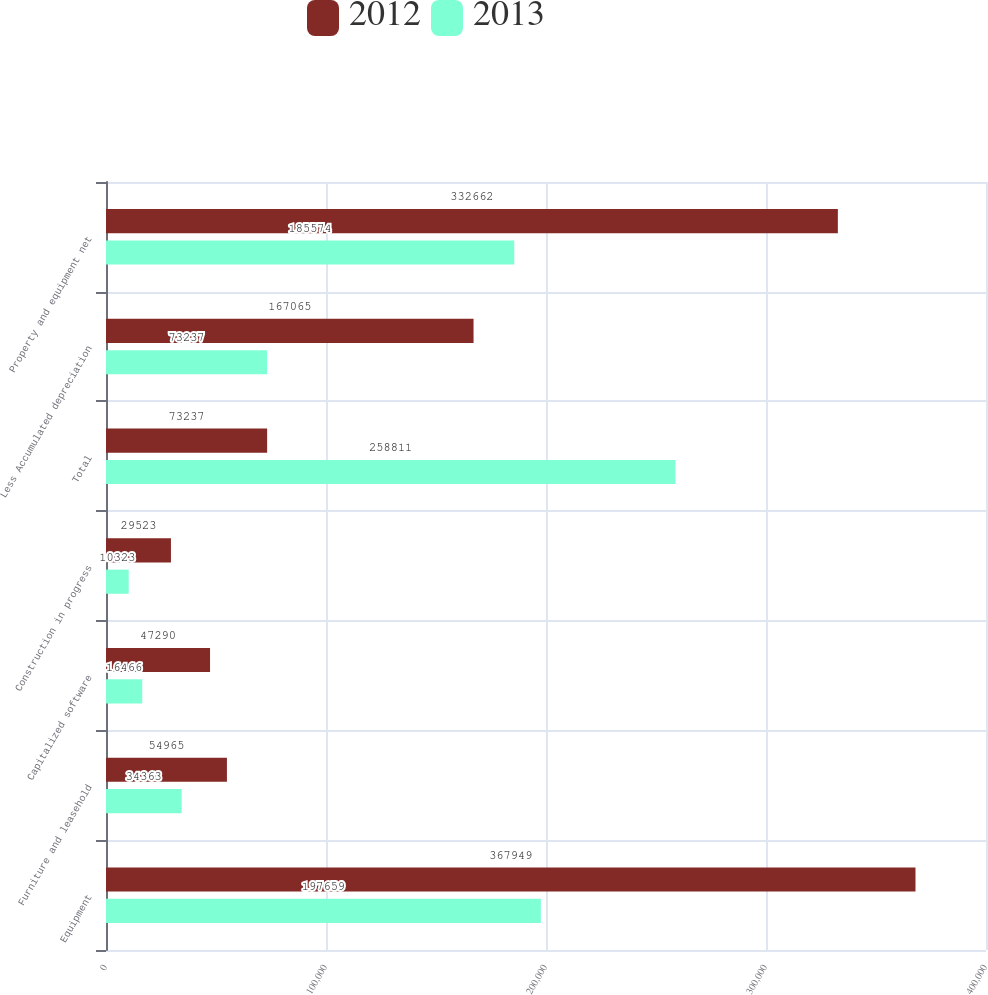Convert chart to OTSL. <chart><loc_0><loc_0><loc_500><loc_500><stacked_bar_chart><ecel><fcel>Equipment<fcel>Furniture and leasehold<fcel>Capitalized software<fcel>Construction in progress<fcel>Total<fcel>Less Accumulated depreciation<fcel>Property and equipment net<nl><fcel>2012<fcel>367949<fcel>54965<fcel>47290<fcel>29523<fcel>73237<fcel>167065<fcel>332662<nl><fcel>2013<fcel>197659<fcel>34363<fcel>16466<fcel>10323<fcel>258811<fcel>73237<fcel>185574<nl></chart> 